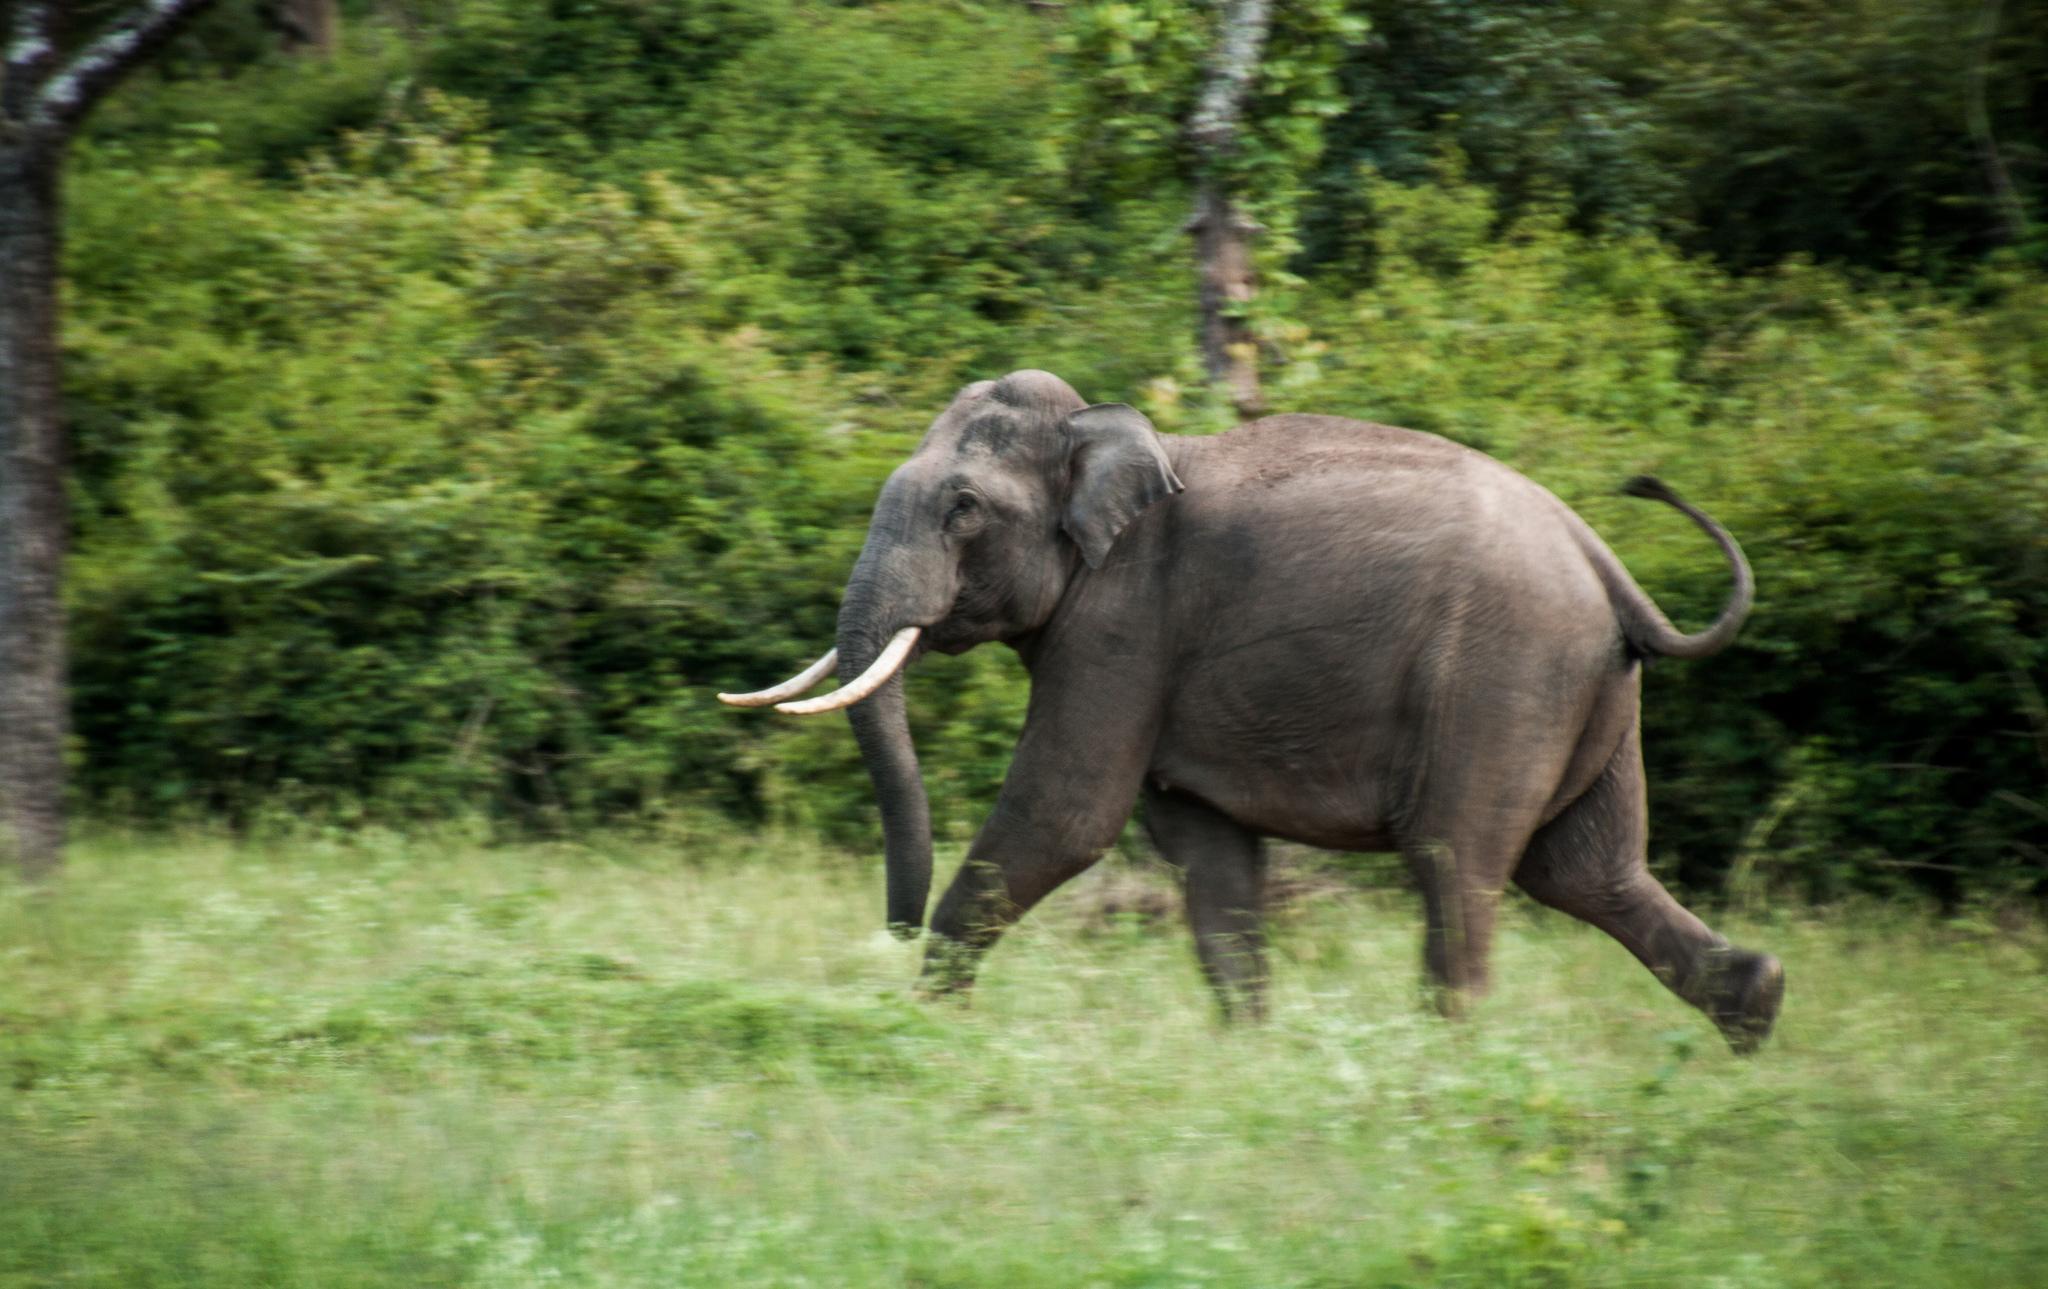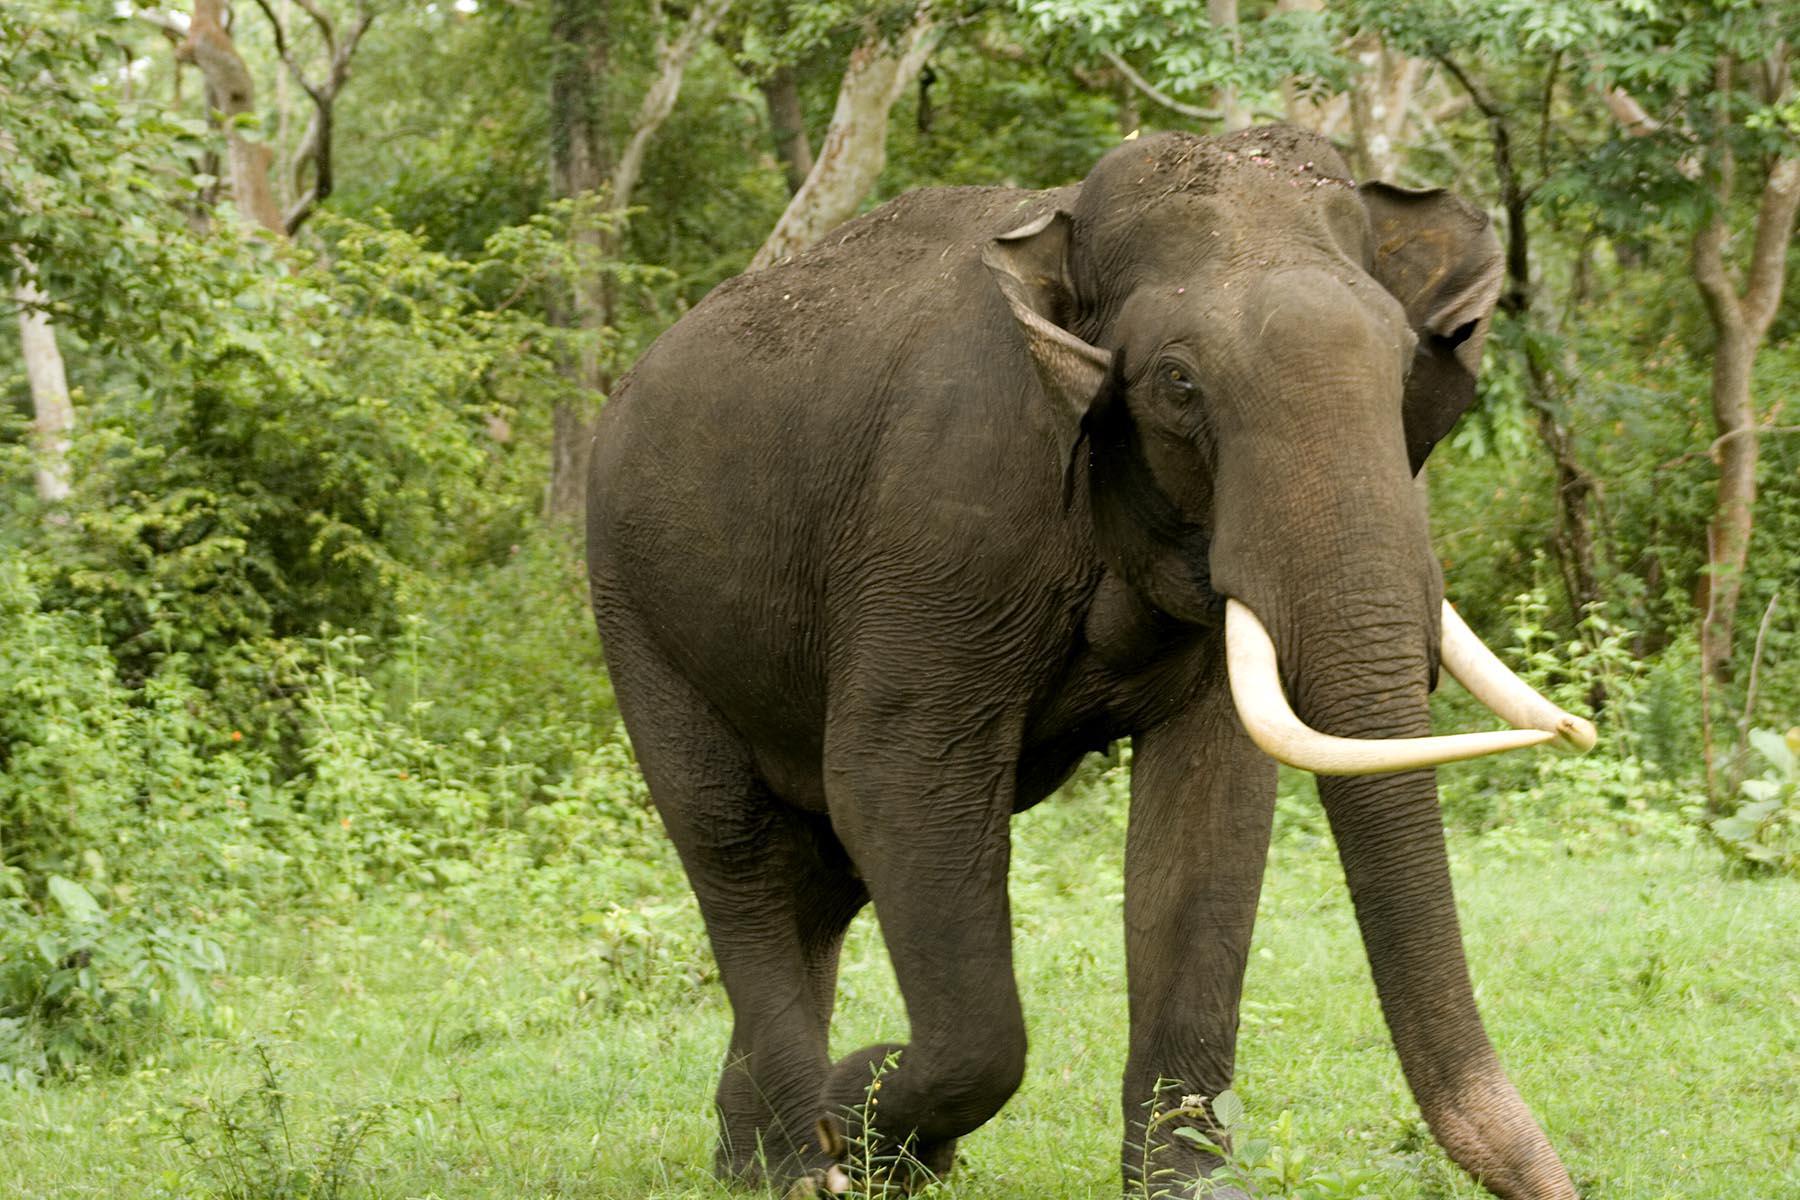The first image is the image on the left, the second image is the image on the right. Considering the images on both sides, is "The right image contains exactly one elephant that is walking towards the right." valid? Answer yes or no. Yes. The first image is the image on the left, the second image is the image on the right. Examine the images to the left and right. Is the description "Both elephants have white tusks." accurate? Answer yes or no. Yes. 